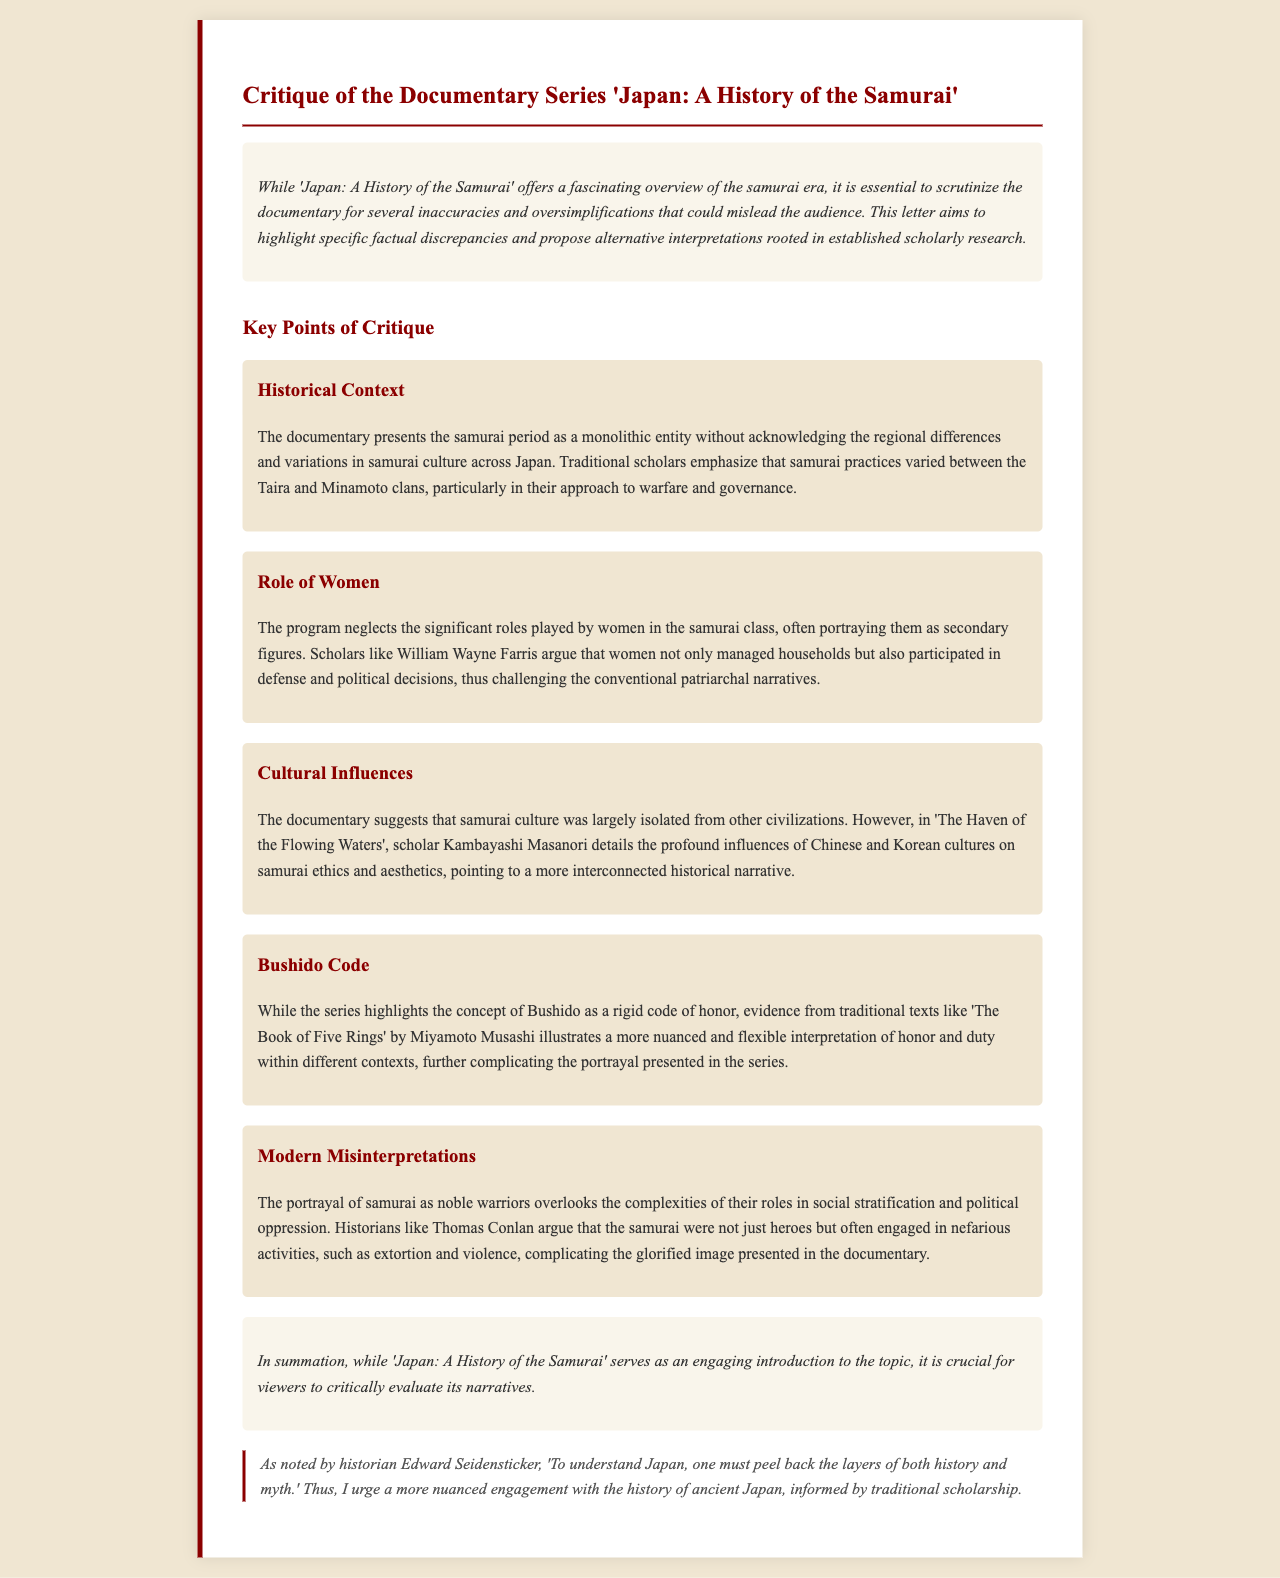What is the title of the documentary critiqued? The document critiques a documentary titled 'Japan: A History of the Samurai'.
Answer: 'Japan: A History of the Samurai' Who argues that women in the samurai class played significant roles? The document mentions William Wayne Farris as a scholar who argues about the roles of women in the samurai class.
Answer: William Wayne Farris What concept does the documentary portray as a rigid code of honor? The documentary highlights the concept of Bushido as a rigid code of honor.
Answer: Bushido Which scholar’s work is referenced regarding cultural influences on samurai culture? The document references Kambayashi Masanori's work for discussing cultural influences on samurai culture.
Answer: Kambayashi Masanori What term describes the samurai's portrayal in the documentary? The samurai are portrayed as noble warriors in the documentary.
Answer: Noble warriors Which document discusses a more nuanced interpretation of honor and duty? 'The Book of Five Rings' by Miyamoto Musashi is mentioned for discussing a nuanced interpretation of honor and duty.
Answer: 'The Book of Five Rings' What does Edward Seidensticker suggest is necessary to understand Japan? Edward Seidensticker suggests that one must peel back the layers of both history and myth to understand Japan.
Answer: Peel back layers of history and myth How many key points of critique are highlighted in the document? The document presents five key points of critique regarding the documentary.
Answer: Five 